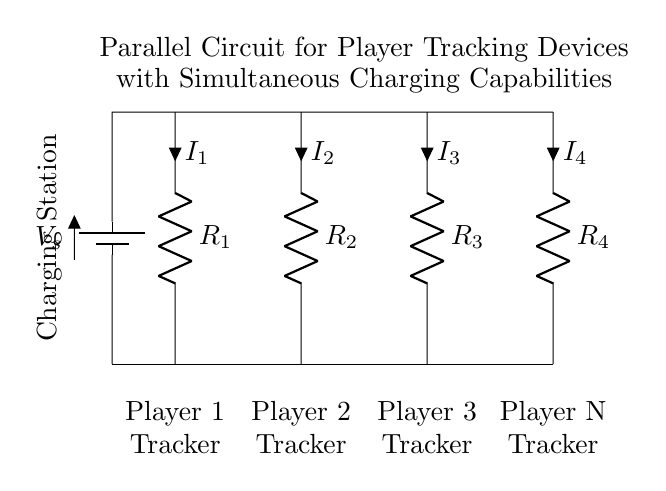What is the total number of players tracked in this circuit? The diagram shows four resistors labeled, each corresponding to a player tracker. This indicates that there are four players being tracked by the devices in the circuit.
Answer: Four What is the role of component V_s in the circuit? The component labeled V_s is a battery, which provides the voltage necessary to power the tracking devices in parallel. It supplies energy to all the players' trackers simultaneously.
Answer: Battery Which component indicates the resistance for Player 2's tracker? The resistor labeled R_2 corresponds to Player 2's tracker. It is connected in the circuit to allow current flow for that specific player device.
Answer: R_2 What happens to the total resistance when one of the player trackers fails? In a parallel circuit, if one resistor (tracker) fails, the total resistance decreases as the remaining resistors continue to provide paths for current. The current will redistribute among the still-functioning devices.
Answer: Decreases How is the charging capability of the circuit indicated? The circuit diagram includes a node labeled "Charging Station" which signifies that the circuit has provisions for charging each of the player trackers while they are in operation, implying simultaneous functionality of tracking and charging.
Answer: Charging Station 